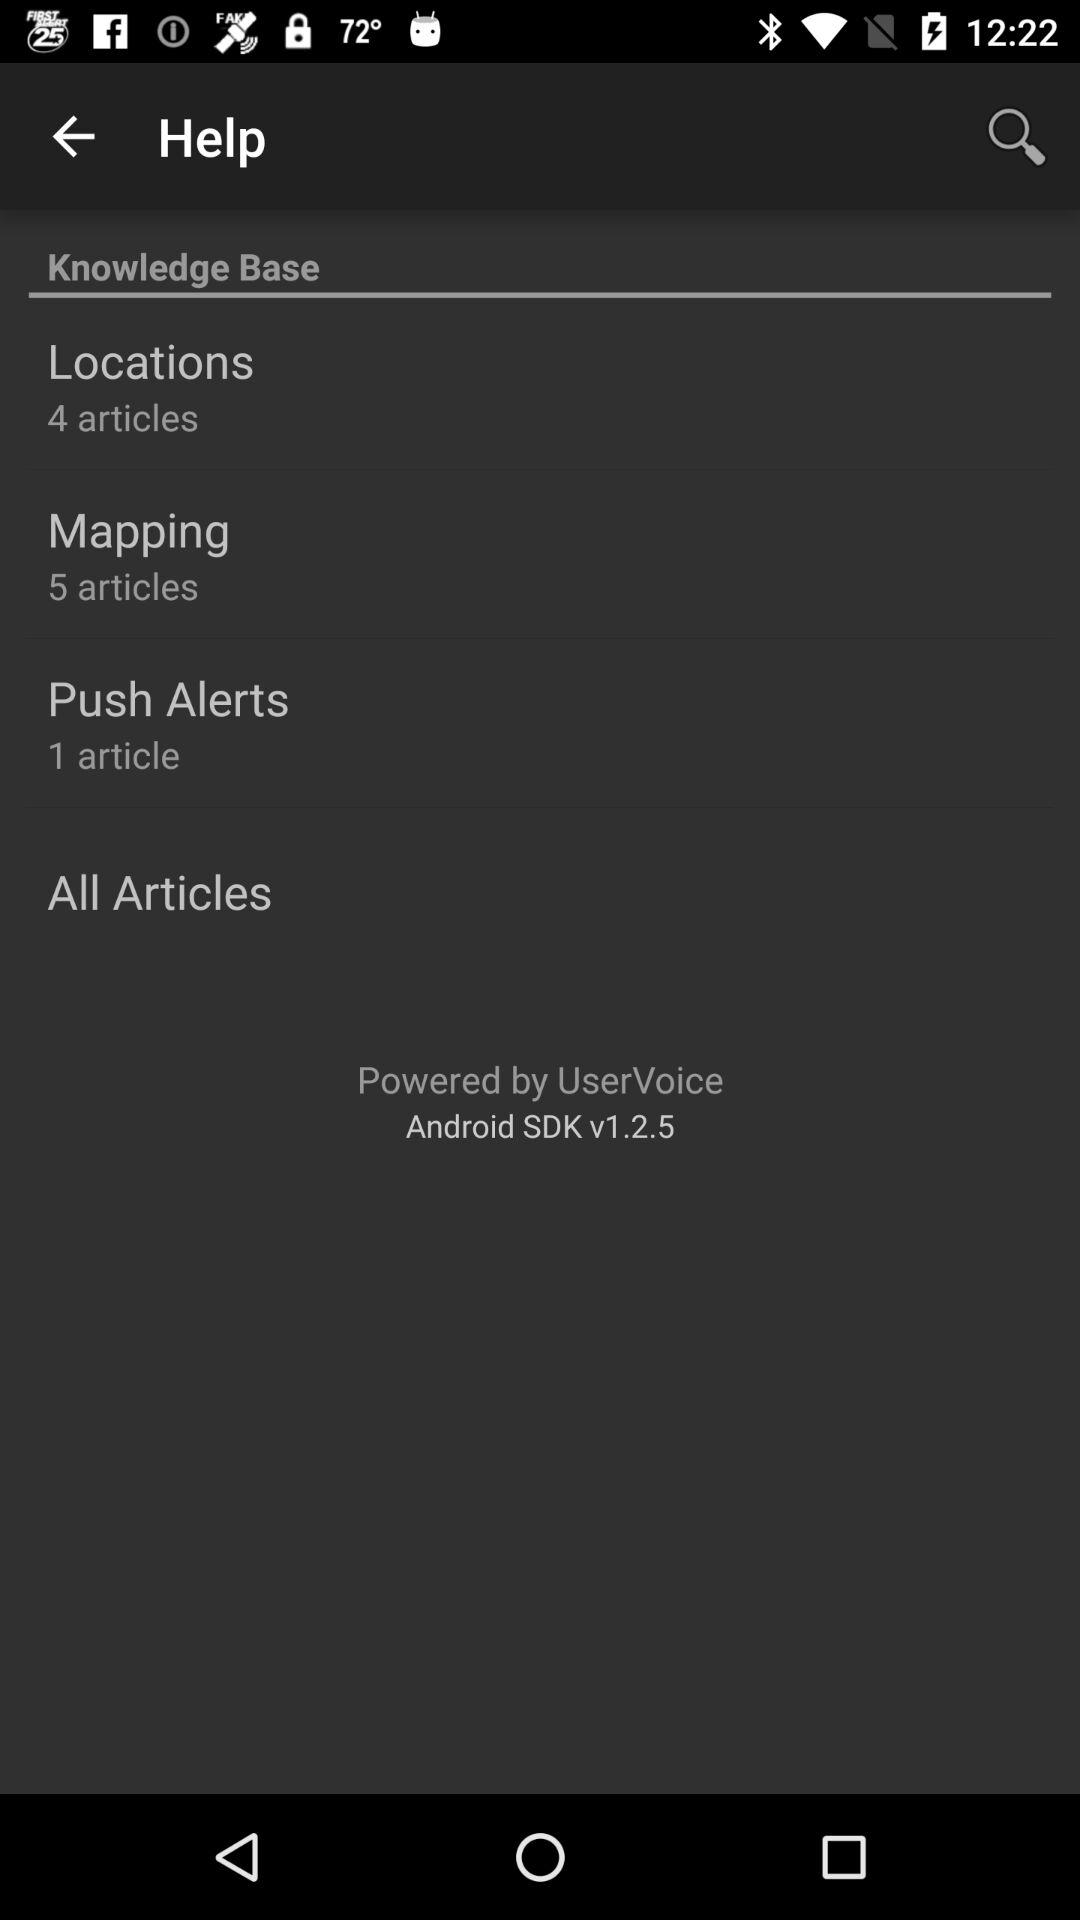What is the version of the application? The version is v1.2.5. 